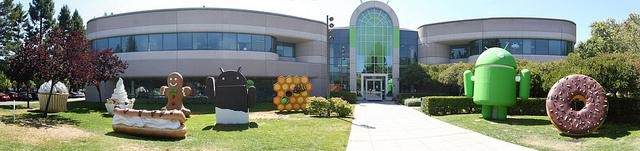What company's mascot can be seen on the right next to the donut? Please explain your reasoning. android. There is an alien. 